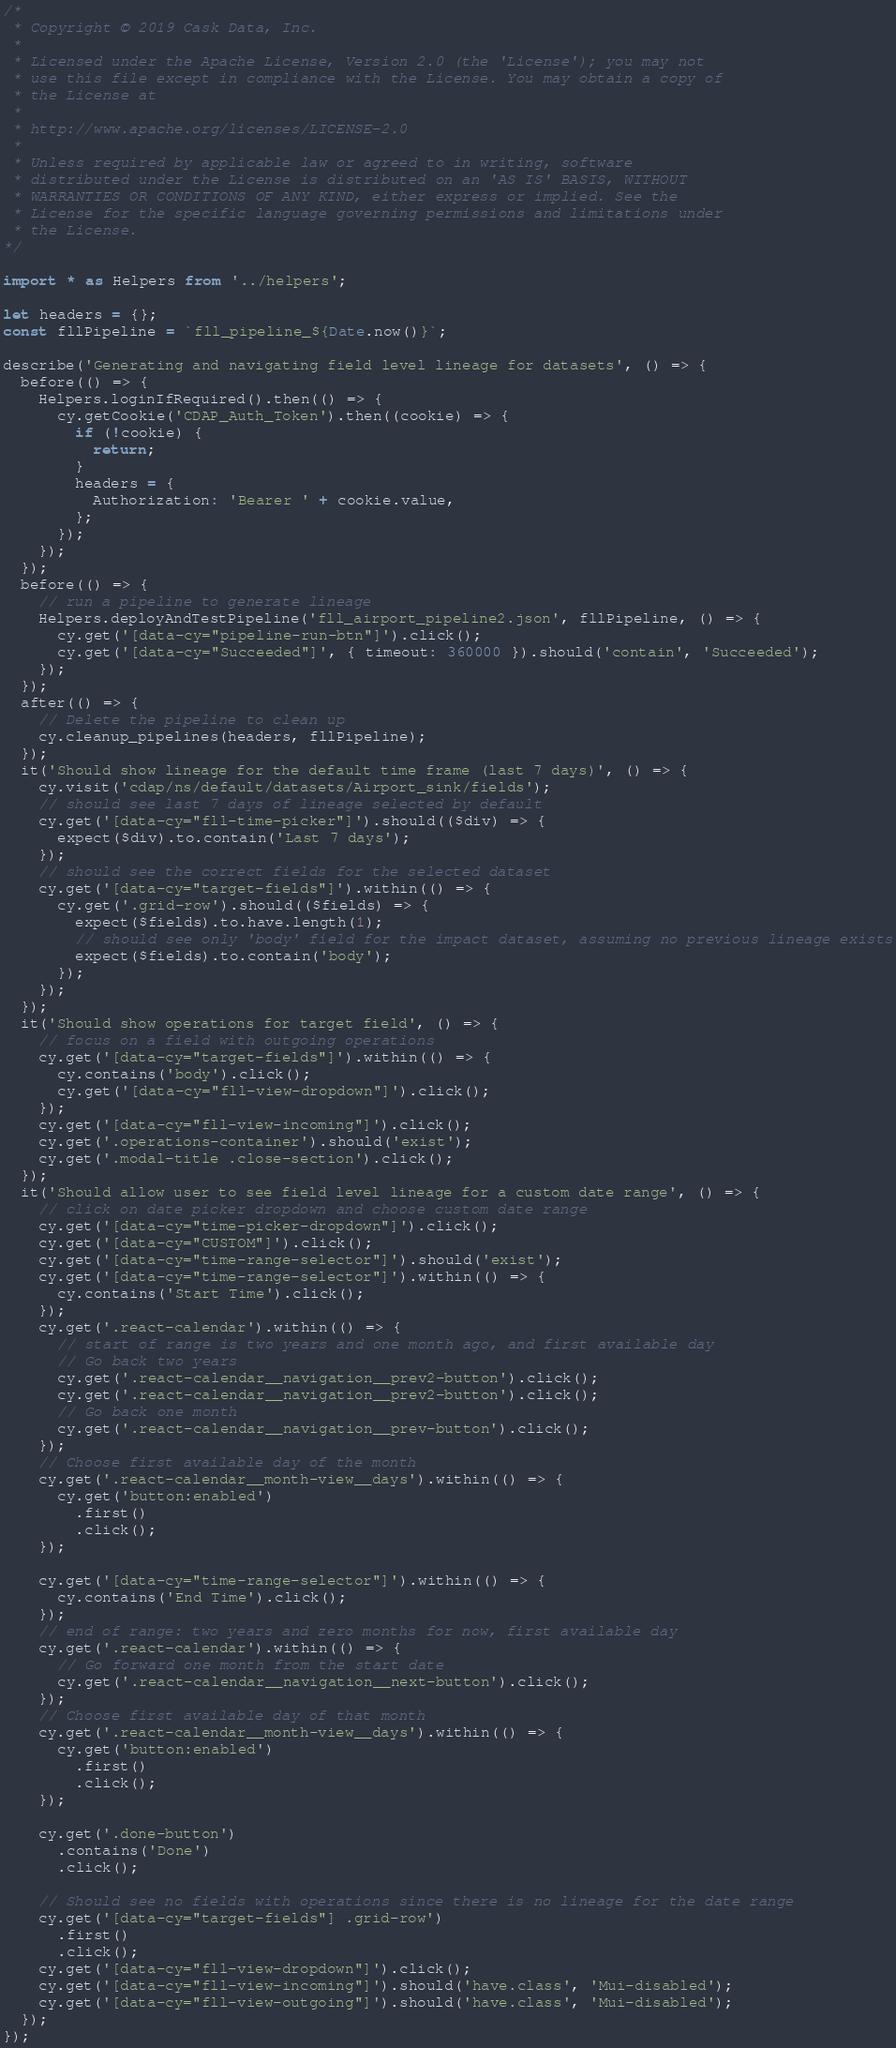Convert code to text. <code><loc_0><loc_0><loc_500><loc_500><_TypeScript_>/*
 * Copyright © 2019 Cask Data, Inc.
 *
 * Licensed under the Apache License, Version 2.0 (the 'License'); you may not
 * use this file except in compliance with the License. You may obtain a copy of
 * the License at
 *
 * http://www.apache.org/licenses/LICENSE-2.0
 *
 * Unless required by applicable law or agreed to in writing, software
 * distributed under the License is distributed on an 'AS IS' BASIS, WITHOUT
 * WARRANTIES OR CONDITIONS OF ANY KIND, either express or implied. See the
 * License for the specific language governing permissions and limitations under
 * the License.
*/

import * as Helpers from '../helpers';

let headers = {};
const fllPipeline = `fll_pipeline_${Date.now()}`;

describe('Generating and navigating field level lineage for datasets', () => {
  before(() => {
    Helpers.loginIfRequired().then(() => {
      cy.getCookie('CDAP_Auth_Token').then((cookie) => {
        if (!cookie) {
          return;
        }
        headers = {
          Authorization: 'Bearer ' + cookie.value,
        };
      });
    });
  });
  before(() => {
    // run a pipeline to generate lineage
    Helpers.deployAndTestPipeline('fll_airport_pipeline2.json', fllPipeline, () => {
      cy.get('[data-cy="pipeline-run-btn"]').click();
      cy.get('[data-cy="Succeeded"]', { timeout: 360000 }).should('contain', 'Succeeded');
    });
  });
  after(() => {
    // Delete the pipeline to clean up
    cy.cleanup_pipelines(headers, fllPipeline);
  });
  it('Should show lineage for the default time frame (last 7 days)', () => {
    cy.visit('cdap/ns/default/datasets/Airport_sink/fields');
    // should see last 7 days of lineage selected by default
    cy.get('[data-cy="fll-time-picker"]').should(($div) => {
      expect($div).to.contain('Last 7 days');
    });
    // should see the correct fields for the selected dataset
    cy.get('[data-cy="target-fields"]').within(() => {
      cy.get('.grid-row').should(($fields) => {
        expect($fields).to.have.length(1);
        // should see only 'body' field for the impact dataset, assuming no previous lineage exists
        expect($fields).to.contain('body');
      });
    });
  });
  it('Should show operations for target field', () => {
    // focus on a field with outgoing operations
    cy.get('[data-cy="target-fields"]').within(() => {
      cy.contains('body').click();
      cy.get('[data-cy="fll-view-dropdown"]').click();
    });
    cy.get('[data-cy="fll-view-incoming"]').click();
    cy.get('.operations-container').should('exist');
    cy.get('.modal-title .close-section').click();
  });
  it('Should allow user to see field level lineage for a custom date range', () => {
    // click on date picker dropdown and choose custom date range
    cy.get('[data-cy="time-picker-dropdown"]').click();
    cy.get('[data-cy="CUSTOM"]').click();
    cy.get('[data-cy="time-range-selector"]').should('exist');
    cy.get('[data-cy="time-range-selector"]').within(() => {
      cy.contains('Start Time').click();
    });
    cy.get('.react-calendar').within(() => {
      // start of range is two years and one month ago, and first available day
      // Go back two years
      cy.get('.react-calendar__navigation__prev2-button').click();
      cy.get('.react-calendar__navigation__prev2-button').click();
      // Go back one month
      cy.get('.react-calendar__navigation__prev-button').click();
    });
    // Choose first available day of the month
    cy.get('.react-calendar__month-view__days').within(() => {
      cy.get('button:enabled')
        .first()
        .click();
    });

    cy.get('[data-cy="time-range-selector"]').within(() => {
      cy.contains('End Time').click();
    });
    // end of range: two years and zero months for now, first available day
    cy.get('.react-calendar').within(() => {
      // Go forward one month from the start date
      cy.get('.react-calendar__navigation__next-button').click();
    });
    // Choose first available day of that month
    cy.get('.react-calendar__month-view__days').within(() => {
      cy.get('button:enabled')
        .first()
        .click();
    });

    cy.get('.done-button')
      .contains('Done')
      .click();

    // Should see no fields with operations since there is no lineage for the date range
    cy.get('[data-cy="target-fields"] .grid-row')
      .first()
      .click();
    cy.get('[data-cy="fll-view-dropdown"]').click();
    cy.get('[data-cy="fll-view-incoming"]').should('have.class', 'Mui-disabled');
    cy.get('[data-cy="fll-view-outgoing"]').should('have.class', 'Mui-disabled');
  });
});
</code> 